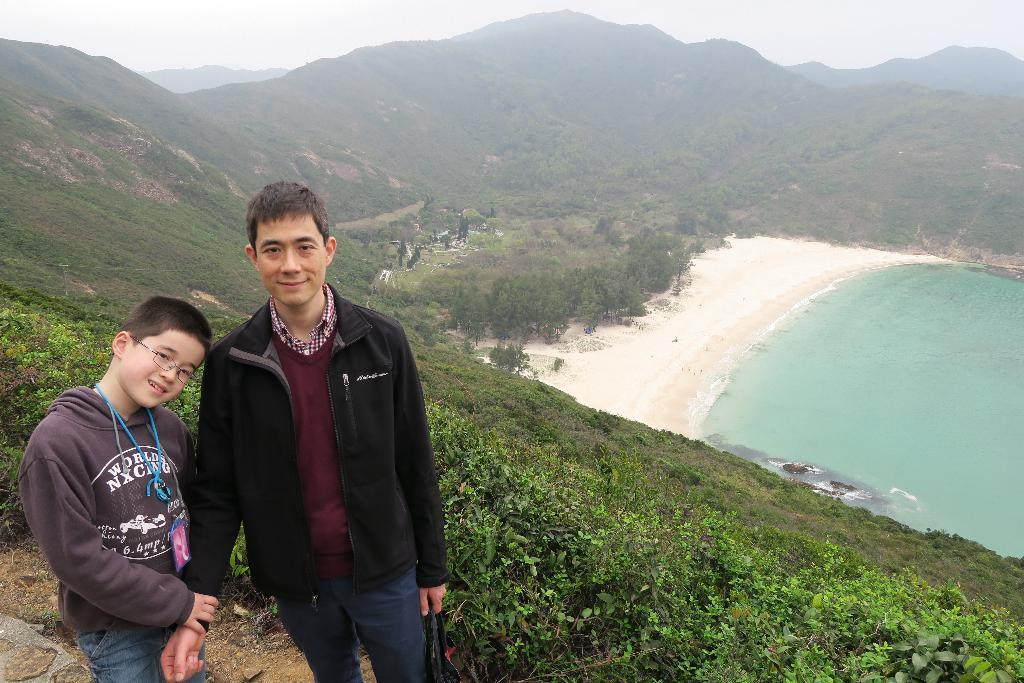How many people are present in the image? There are two people standing in the image. What is visible in the background of the image? There is water, trees, hills, and fog in the background of the image. What part of the natural environment can be seen in the image? The sky is visible in the image. What language are the people discussing in the image? There is no discussion or language present in the image, as it only shows two people standing in a natural environment. 